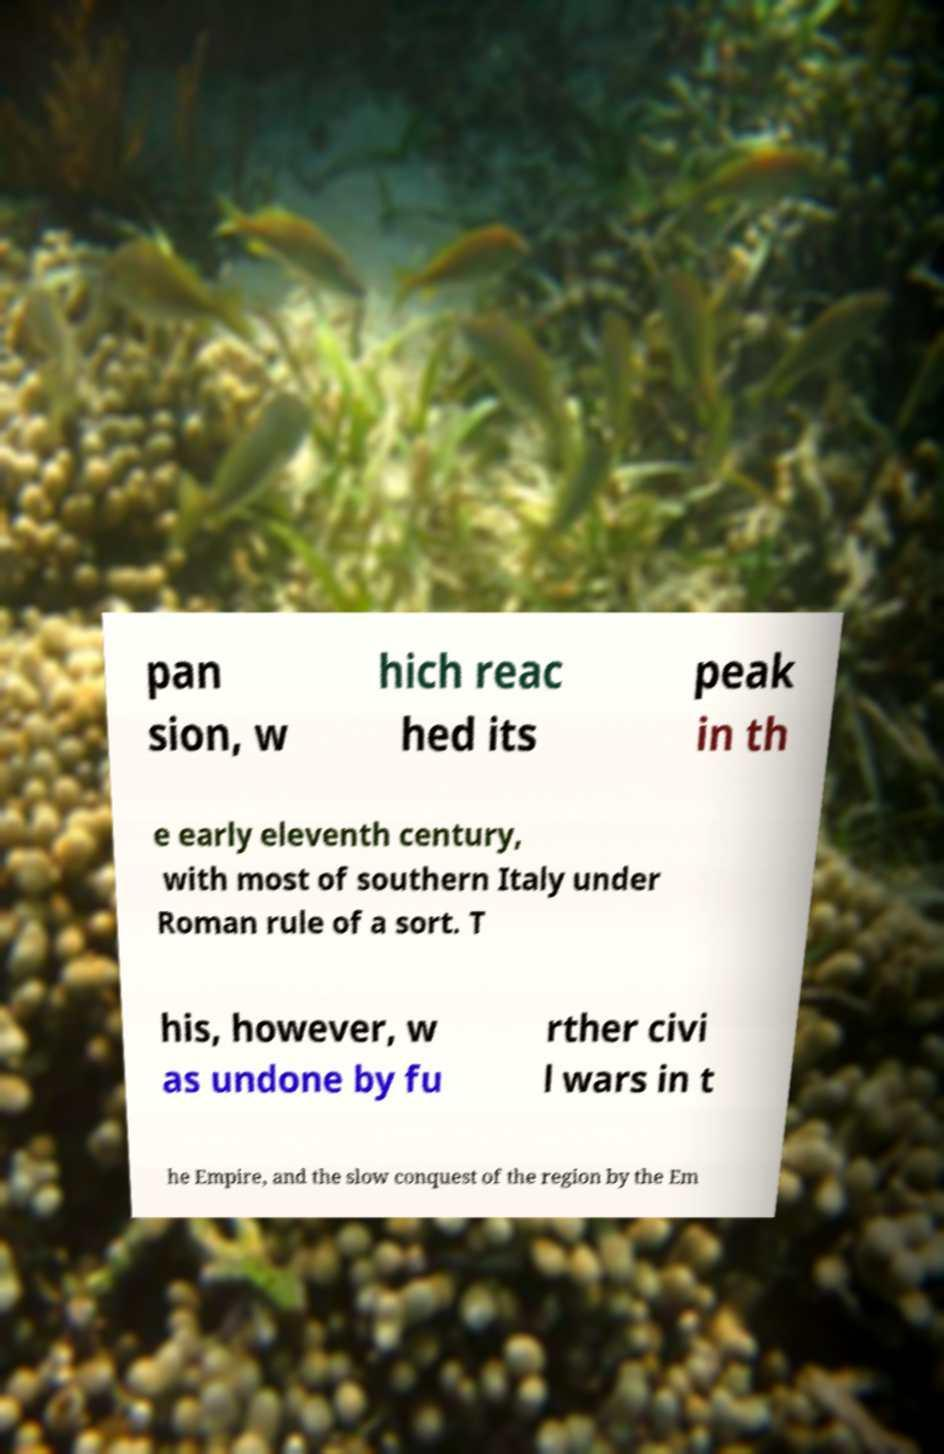For documentation purposes, I need the text within this image transcribed. Could you provide that? pan sion, w hich reac hed its peak in th e early eleventh century, with most of southern Italy under Roman rule of a sort. T his, however, w as undone by fu rther civi l wars in t he Empire, and the slow conquest of the region by the Em 